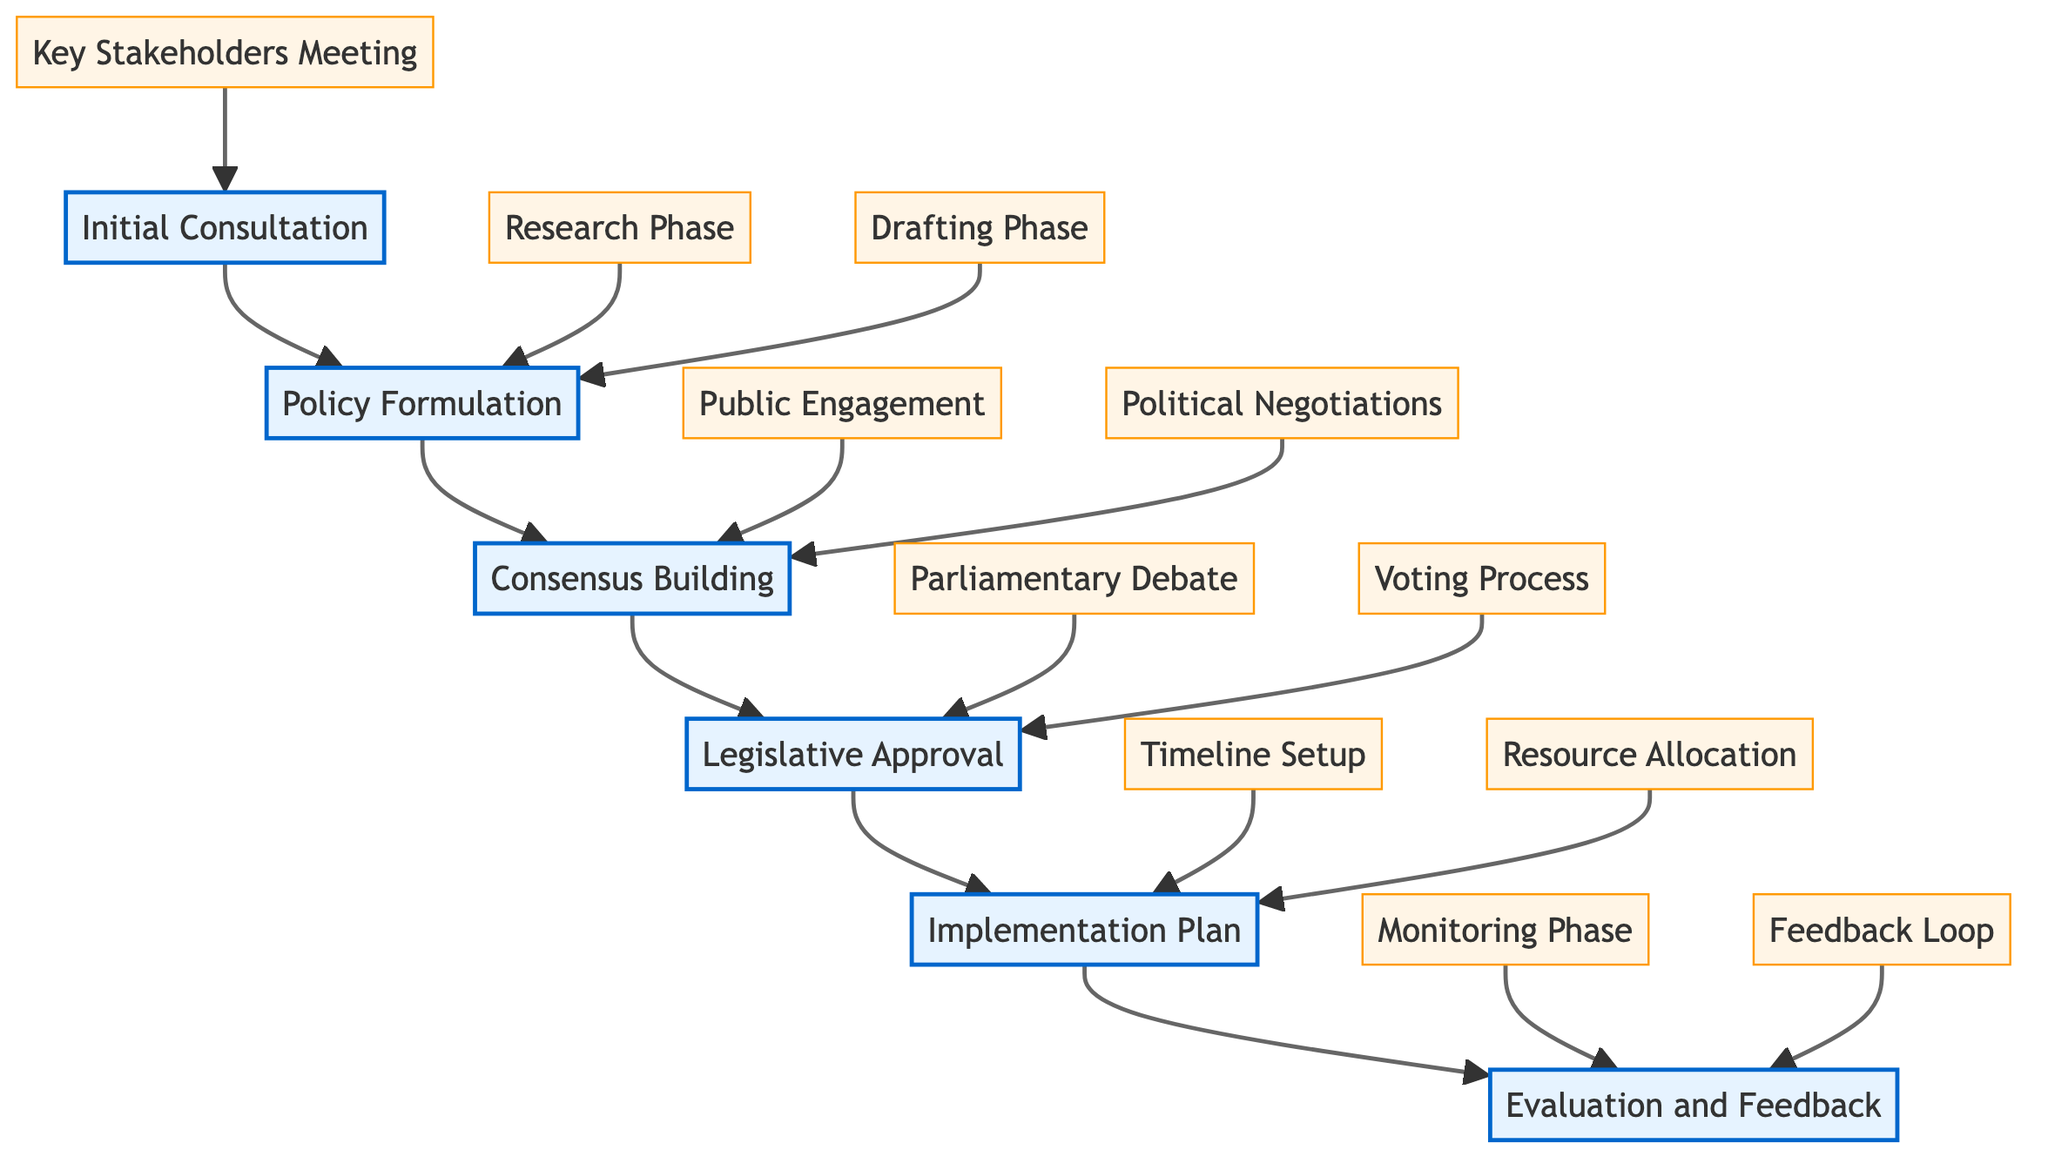What are the key stakeholders involved in the initial consultation? By examining the "Initial Consultation" node, we can see explicitly listed the stakeholders: "Health Minister's Office," "National Medical Association," and "Major Political Parties." This information is derived directly from the sub-node "Key Stakeholders Meeting."
Answer: Health Minister's Office, National Medical Association, Major Political Parties How many phases are there in the clinical pathway? The main nodes in the diagram represent the distinct phases of the pathway. There are six phases: "Initial Consultation," "Policy Formulation," "Consensus Building," "Legislative Approval," "Implementation Plan," and "Evaluation and Feedback." Counting these gives us the total number of phases.
Answer: 6 What phase comes after "Policy Formulation"? By following the flow from the "Policy Formulation" node, the next node in the sequence is "Consensus Building." This relationship is established by the directed arrows connecting the phases.
Answer: Consensus Building Which phase includes public engagement activities? The "Consensus Building" phase contains the sub-node labeled "Public Engagement," which lists activities that involve the public, specifically "Town Hall Meetings" and "Public Opinion Polls." This can be directly identified from the diagram flow.
Answer: Consensus Building What are the two components of the legislative approval process? In the "Legislative Approval" node, the specific components are detailed as "Parliamentary Debate" and "Voting Process." These components illustrate the successive steps within this phase in the clinical pathway.
Answer: Parliamentary Debate, Voting Process During which phase is resource allocation planned? Referring to the "Implementation Plan," the sub-node "Resource Allocation" indicates that this is the phase where resource allocation is organized. This can be easily confirmed by reviewing the phases and their sub-components.
Answer: Implementation Plan What type of meetings are included in public engagement? The "Public Engagement" sub-node under the "Consensus Building" phase lists "Town Hall Meetings" and "Public Opinion Polls" as the specific types of meetings organized for public engagement in the health reform strategy.
Answer: Town Hall Meetings, Public Opinion Polls What follows the feedback loop in the evaluation process? Upon analyzing the last phase, "Evaluation and Feedback," the diagram indicates that the "Feedback Loop" occurs at the end of this phase, meaning there are no subsequent phases following it. Hence, there are no further activities outlined after this loop.
Answer: None 